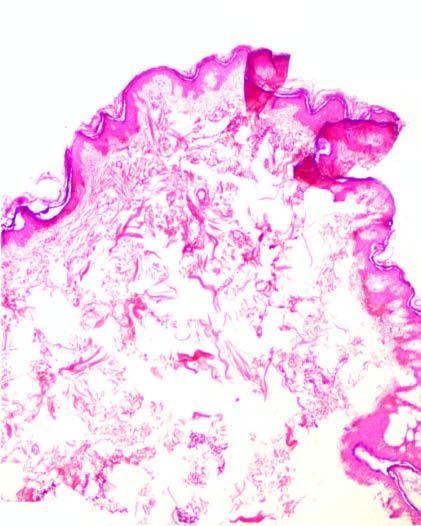s the epidermis raised as polypoid mass over dense hyalinised fibrous connective tissue in the dermis?
Answer the question using a single word or phrase. Yes 